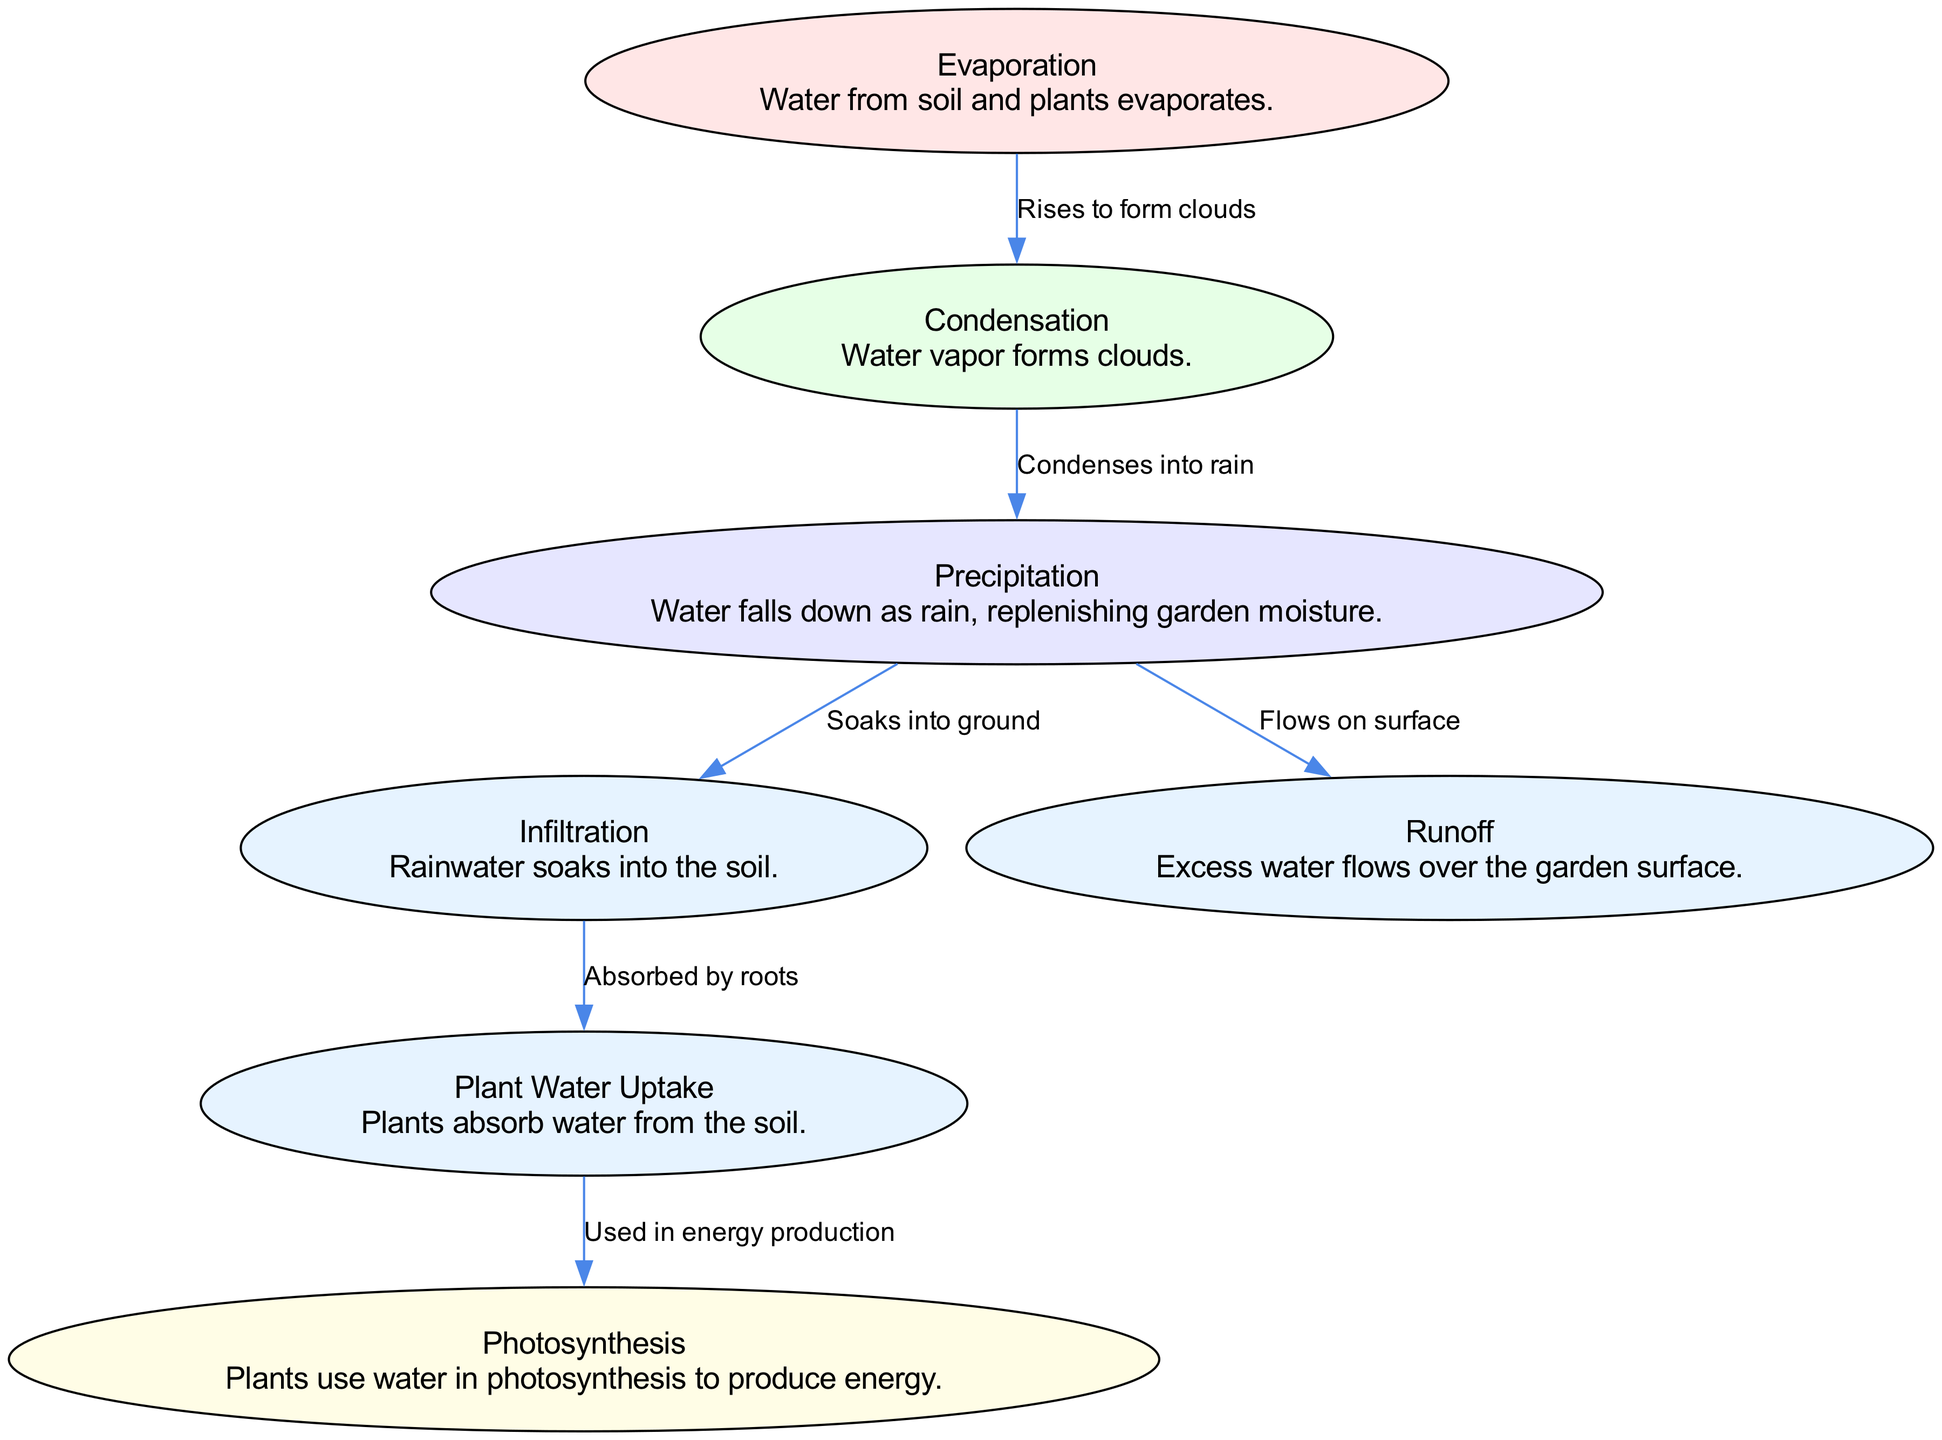What process leads to cloud formation? The process that leads to cloud formation in the diagram is "Evaporation" where water from soil and plants evaporates and rises into the atmosphere, eventually forming clouds through condensation.
Answer: Evaporation How many nodes are present in the diagram? The diagram contains a total of 7 nodes representing different processes in the water cycle, including evaporation, condensation, precipitation, infiltration, runoff, plant water uptake, and photosynthesis.
Answer: 7 What is the output of precipitation? The output of precipitation in the diagram leads to two possible outcomes: infiltration, where the rainwater soaks into the ground, and runoff, where the excess water flows over the garden surface.
Answer: Infiltration and runoff Which process uses water for energy production? The process that uses water for energy production in the diagram is "Photosynthesis," where plants utilize water absorbed through their roots to create energy.
Answer: Photosynthesis What connects evaporation and condensation in the diagram? The connection between evaporation and condensation in the diagram is represented by an edge labeled "Rises to form clouds," indicating the transition from water vapor due to evaporation that subsequently condenses.
Answer: Rises to form clouds What process comes after infiltration in the water cycle? After the infiltration process, the next step involves "Plant Water Uptake," where plants absorb the water that has soaked into the soil through their roots for nourishment.
Answer: Plant Water Uptake How does precipitation contribute to garden health? Precipitation contributes to garden health by replenishing moisture in the garden through infiltration, which allows plants to absorb necessary water for growth, thus supporting their health during periods of fasting.
Answer: Replenishing moisture Which process is responsible for plant water absorption? The process responsible for plant water absorption is "Plant Water Uptake," as depicted in the diagram, where water that infiltrates into the soil is absorbed by the roots of the plants.
Answer: Plant Water Uptake 